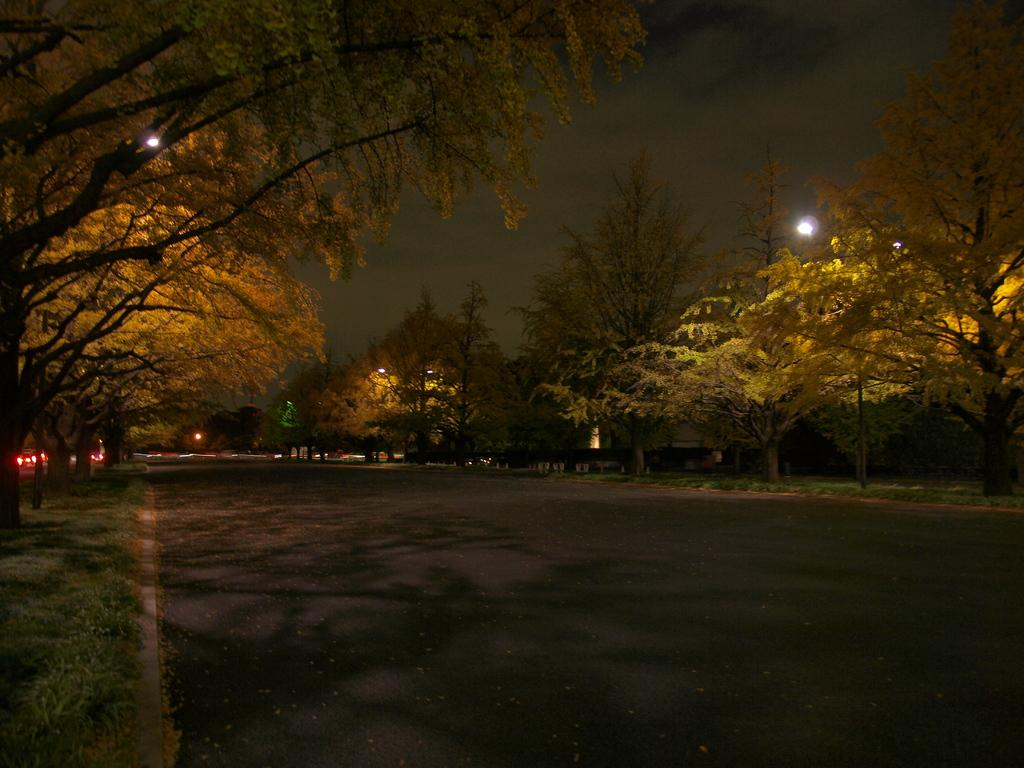What time of day was the image taken? The image was taken during night. What can be seen on the ground in the image? There is a road in the image. What is visible in the background of the image? The sky is visible in the image. What can be seen illuminating the scene in the image? There are lights visible in the image. What type of vegetation is present in the image? Grass is present in the image. Where is the shelf located in the image? There is no shelf present in the image. What type of pest can be seen crawling on the grass in the image? There are no pests visible in the image; it only shows a road, sky, lights, and grass. 